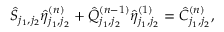Convert formula to latex. <formula><loc_0><loc_0><loc_500><loc_500>\hat { S } _ { j _ { 1 } , j _ { 2 } } \hat { \eta } _ { j _ { 1 } , j _ { 2 } } ^ { ( n ) } + \hat { Q } _ { j _ { 1 } , j _ { 2 } } ^ { ( n - 1 ) } \hat { \eta } _ { j _ { 1 } , j _ { 2 } } ^ { ( 1 ) } = \hat { C } _ { j _ { 1 } , j _ { 2 } } ^ { ( n ) } ,</formula> 